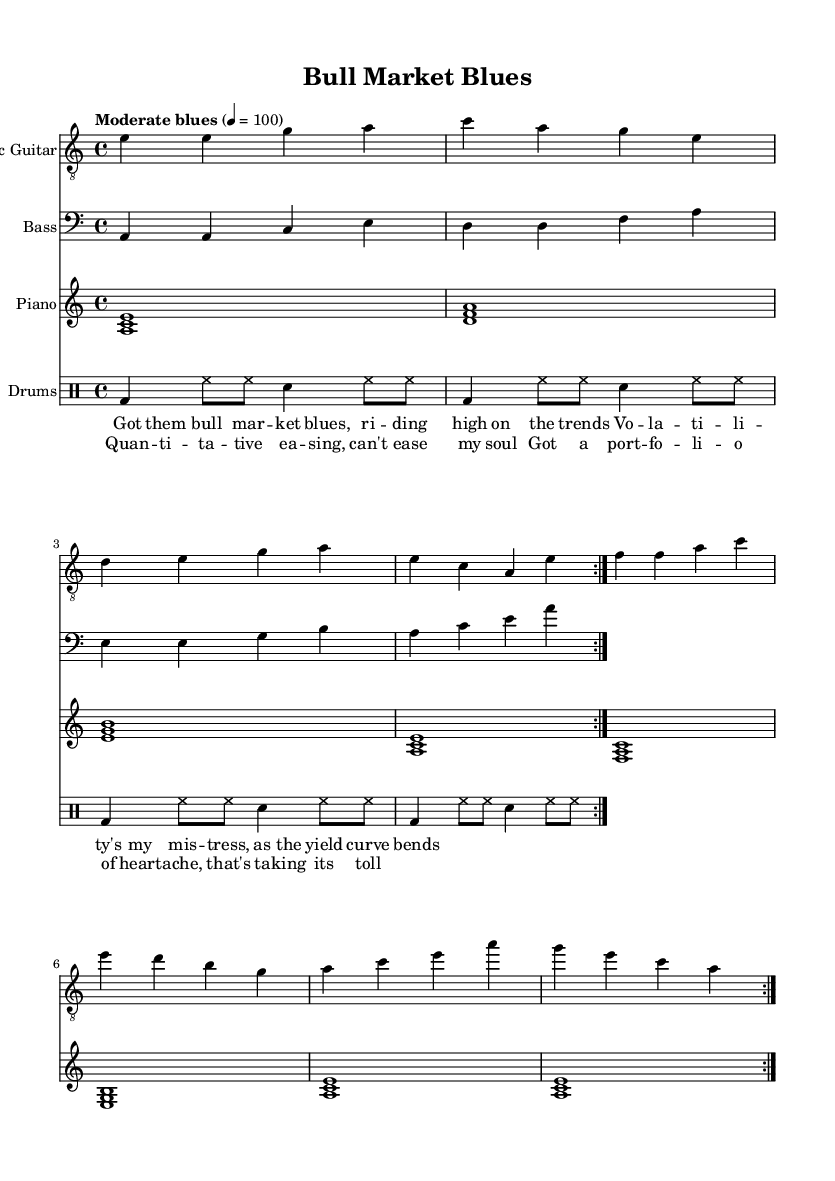What is the key signature of this music? The key signature is A minor, which is indicated at the beginning of the piece. A minor has no sharps or flats.
Answer: A minor What is the time signature of the piece? The time signature is 4/4, which is shown at the beginning of the music. This means there are four beats in each measure.
Answer: 4/4 What is the tempo marking for this music? The tempo marking is "Moderate blues," which suggests a relaxed pace typical of the blues genre, specifically with a tempo of 100 beats per minute.
Answer: Moderate blues How many times is the electric guitar section repeated? The electric guitar section is indicated to be repeated with the "volta" marking, which suggests it is played two times.
Answer: 2 What is the main theme of the lyrics? The lyrics express feelings of grief and anxiety related to financial markets, referencing volatility and portfolio struggles, which relate to the emotional weight often found in blues music.
Answer: Financial struggle How many different instruments are present in the score? The score includes four different instruments: Electric Guitar, Bass, Piano, and Drums. Each is notated separately in the score.
Answer: 4 What is the dynamic marking or style indicated in the piece? The piece is characterized as a moderate blues style, described through the tempo marking, which suggests a laid-back feel typical of blues music.
Answer: Blues style 